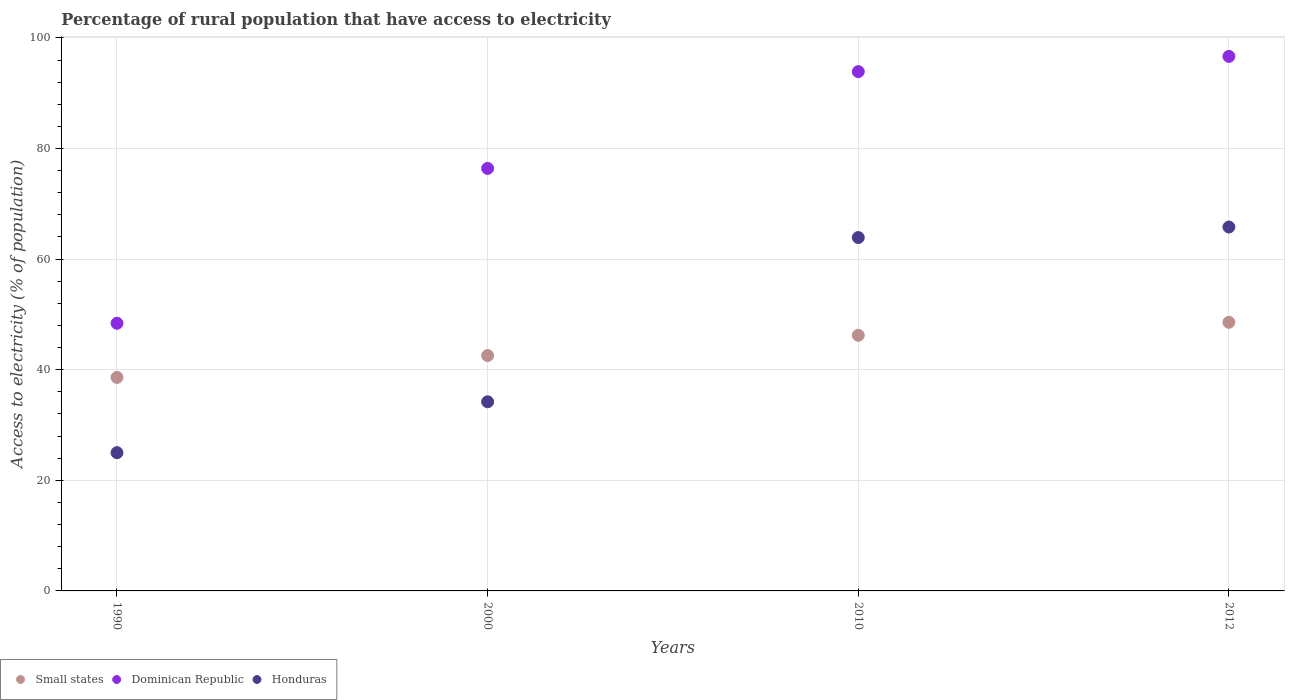How many different coloured dotlines are there?
Ensure brevity in your answer.  3. What is the percentage of rural population that have access to electricity in Small states in 2000?
Your response must be concise. 42.56. Across all years, what is the maximum percentage of rural population that have access to electricity in Dominican Republic?
Provide a succinct answer. 96.65. Across all years, what is the minimum percentage of rural population that have access to electricity in Honduras?
Offer a terse response. 25. In which year was the percentage of rural population that have access to electricity in Small states maximum?
Your answer should be compact. 2012. In which year was the percentage of rural population that have access to electricity in Honduras minimum?
Make the answer very short. 1990. What is the total percentage of rural population that have access to electricity in Dominican Republic in the graph?
Offer a terse response. 315.35. What is the difference between the percentage of rural population that have access to electricity in Small states in 1990 and that in 2012?
Offer a terse response. -9.96. What is the difference between the percentage of rural population that have access to electricity in Small states in 1990 and the percentage of rural population that have access to electricity in Dominican Republic in 2012?
Ensure brevity in your answer.  -58.05. What is the average percentage of rural population that have access to electricity in Small states per year?
Make the answer very short. 43.99. In the year 2000, what is the difference between the percentage of rural population that have access to electricity in Dominican Republic and percentage of rural population that have access to electricity in Honduras?
Keep it short and to the point. 42.2. What is the ratio of the percentage of rural population that have access to electricity in Small states in 1990 to that in 2000?
Offer a very short reply. 0.91. Is the percentage of rural population that have access to electricity in Small states in 2000 less than that in 2010?
Make the answer very short. Yes. Is the difference between the percentage of rural population that have access to electricity in Dominican Republic in 1990 and 2000 greater than the difference between the percentage of rural population that have access to electricity in Honduras in 1990 and 2000?
Offer a terse response. No. What is the difference between the highest and the second highest percentage of rural population that have access to electricity in Small states?
Your response must be concise. 2.35. What is the difference between the highest and the lowest percentage of rural population that have access to electricity in Dominican Republic?
Offer a very short reply. 48.25. Is it the case that in every year, the sum of the percentage of rural population that have access to electricity in Dominican Republic and percentage of rural population that have access to electricity in Honduras  is greater than the percentage of rural population that have access to electricity in Small states?
Your answer should be compact. Yes. Is the percentage of rural population that have access to electricity in Small states strictly greater than the percentage of rural population that have access to electricity in Dominican Republic over the years?
Ensure brevity in your answer.  No. How many years are there in the graph?
Keep it short and to the point. 4. What is the difference between two consecutive major ticks on the Y-axis?
Make the answer very short. 20. Does the graph contain any zero values?
Offer a very short reply. No. Where does the legend appear in the graph?
Make the answer very short. Bottom left. How many legend labels are there?
Offer a very short reply. 3. How are the legend labels stacked?
Give a very brief answer. Horizontal. What is the title of the graph?
Make the answer very short. Percentage of rural population that have access to electricity. What is the label or title of the Y-axis?
Your response must be concise. Access to electricity (% of population). What is the Access to electricity (% of population) of Small states in 1990?
Offer a terse response. 38.61. What is the Access to electricity (% of population) in Dominican Republic in 1990?
Offer a very short reply. 48.4. What is the Access to electricity (% of population) in Honduras in 1990?
Offer a very short reply. 25. What is the Access to electricity (% of population) of Small states in 2000?
Provide a succinct answer. 42.56. What is the Access to electricity (% of population) of Dominican Republic in 2000?
Offer a terse response. 76.4. What is the Access to electricity (% of population) of Honduras in 2000?
Your response must be concise. 34.2. What is the Access to electricity (% of population) of Small states in 2010?
Offer a terse response. 46.22. What is the Access to electricity (% of population) in Dominican Republic in 2010?
Offer a terse response. 93.9. What is the Access to electricity (% of population) in Honduras in 2010?
Make the answer very short. 63.9. What is the Access to electricity (% of population) in Small states in 2012?
Provide a short and direct response. 48.57. What is the Access to electricity (% of population) in Dominican Republic in 2012?
Ensure brevity in your answer.  96.65. What is the Access to electricity (% of population) of Honduras in 2012?
Your response must be concise. 65.8. Across all years, what is the maximum Access to electricity (% of population) in Small states?
Offer a terse response. 48.57. Across all years, what is the maximum Access to electricity (% of population) of Dominican Republic?
Your response must be concise. 96.65. Across all years, what is the maximum Access to electricity (% of population) in Honduras?
Give a very brief answer. 65.8. Across all years, what is the minimum Access to electricity (% of population) of Small states?
Keep it short and to the point. 38.61. Across all years, what is the minimum Access to electricity (% of population) of Dominican Republic?
Ensure brevity in your answer.  48.4. What is the total Access to electricity (% of population) in Small states in the graph?
Provide a short and direct response. 175.96. What is the total Access to electricity (% of population) in Dominican Republic in the graph?
Offer a very short reply. 315.35. What is the total Access to electricity (% of population) of Honduras in the graph?
Offer a terse response. 188.9. What is the difference between the Access to electricity (% of population) of Small states in 1990 and that in 2000?
Keep it short and to the point. -3.95. What is the difference between the Access to electricity (% of population) of Honduras in 1990 and that in 2000?
Offer a very short reply. -9.2. What is the difference between the Access to electricity (% of population) of Small states in 1990 and that in 2010?
Offer a terse response. -7.62. What is the difference between the Access to electricity (% of population) of Dominican Republic in 1990 and that in 2010?
Your answer should be very brief. -45.5. What is the difference between the Access to electricity (% of population) in Honduras in 1990 and that in 2010?
Provide a succinct answer. -38.9. What is the difference between the Access to electricity (% of population) in Small states in 1990 and that in 2012?
Your answer should be very brief. -9.96. What is the difference between the Access to electricity (% of population) in Dominican Republic in 1990 and that in 2012?
Ensure brevity in your answer.  -48.25. What is the difference between the Access to electricity (% of population) in Honduras in 1990 and that in 2012?
Make the answer very short. -40.8. What is the difference between the Access to electricity (% of population) in Small states in 2000 and that in 2010?
Your answer should be very brief. -3.66. What is the difference between the Access to electricity (% of population) of Dominican Republic in 2000 and that in 2010?
Your answer should be very brief. -17.5. What is the difference between the Access to electricity (% of population) in Honduras in 2000 and that in 2010?
Your response must be concise. -29.7. What is the difference between the Access to electricity (% of population) in Small states in 2000 and that in 2012?
Make the answer very short. -6.01. What is the difference between the Access to electricity (% of population) in Dominican Republic in 2000 and that in 2012?
Offer a terse response. -20.25. What is the difference between the Access to electricity (% of population) of Honduras in 2000 and that in 2012?
Provide a short and direct response. -31.6. What is the difference between the Access to electricity (% of population) of Small states in 2010 and that in 2012?
Offer a very short reply. -2.35. What is the difference between the Access to electricity (% of population) in Dominican Republic in 2010 and that in 2012?
Make the answer very short. -2.75. What is the difference between the Access to electricity (% of population) in Honduras in 2010 and that in 2012?
Ensure brevity in your answer.  -1.9. What is the difference between the Access to electricity (% of population) in Small states in 1990 and the Access to electricity (% of population) in Dominican Republic in 2000?
Your answer should be very brief. -37.79. What is the difference between the Access to electricity (% of population) in Small states in 1990 and the Access to electricity (% of population) in Honduras in 2000?
Keep it short and to the point. 4.41. What is the difference between the Access to electricity (% of population) of Dominican Republic in 1990 and the Access to electricity (% of population) of Honduras in 2000?
Your answer should be compact. 14.2. What is the difference between the Access to electricity (% of population) of Small states in 1990 and the Access to electricity (% of population) of Dominican Republic in 2010?
Make the answer very short. -55.29. What is the difference between the Access to electricity (% of population) of Small states in 1990 and the Access to electricity (% of population) of Honduras in 2010?
Offer a terse response. -25.29. What is the difference between the Access to electricity (% of population) in Dominican Republic in 1990 and the Access to electricity (% of population) in Honduras in 2010?
Provide a succinct answer. -15.5. What is the difference between the Access to electricity (% of population) of Small states in 1990 and the Access to electricity (% of population) of Dominican Republic in 2012?
Ensure brevity in your answer.  -58.05. What is the difference between the Access to electricity (% of population) of Small states in 1990 and the Access to electricity (% of population) of Honduras in 2012?
Your response must be concise. -27.19. What is the difference between the Access to electricity (% of population) of Dominican Republic in 1990 and the Access to electricity (% of population) of Honduras in 2012?
Offer a very short reply. -17.4. What is the difference between the Access to electricity (% of population) of Small states in 2000 and the Access to electricity (% of population) of Dominican Republic in 2010?
Your answer should be very brief. -51.34. What is the difference between the Access to electricity (% of population) in Small states in 2000 and the Access to electricity (% of population) in Honduras in 2010?
Provide a succinct answer. -21.34. What is the difference between the Access to electricity (% of population) in Small states in 2000 and the Access to electricity (% of population) in Dominican Republic in 2012?
Offer a terse response. -54.09. What is the difference between the Access to electricity (% of population) in Small states in 2000 and the Access to electricity (% of population) in Honduras in 2012?
Provide a short and direct response. -23.24. What is the difference between the Access to electricity (% of population) in Dominican Republic in 2000 and the Access to electricity (% of population) in Honduras in 2012?
Ensure brevity in your answer.  10.6. What is the difference between the Access to electricity (% of population) in Small states in 2010 and the Access to electricity (% of population) in Dominican Republic in 2012?
Offer a terse response. -50.43. What is the difference between the Access to electricity (% of population) of Small states in 2010 and the Access to electricity (% of population) of Honduras in 2012?
Make the answer very short. -19.58. What is the difference between the Access to electricity (% of population) in Dominican Republic in 2010 and the Access to electricity (% of population) in Honduras in 2012?
Your answer should be very brief. 28.1. What is the average Access to electricity (% of population) in Small states per year?
Make the answer very short. 43.99. What is the average Access to electricity (% of population) in Dominican Republic per year?
Your answer should be compact. 78.84. What is the average Access to electricity (% of population) in Honduras per year?
Offer a very short reply. 47.23. In the year 1990, what is the difference between the Access to electricity (% of population) in Small states and Access to electricity (% of population) in Dominican Republic?
Your response must be concise. -9.79. In the year 1990, what is the difference between the Access to electricity (% of population) in Small states and Access to electricity (% of population) in Honduras?
Your answer should be compact. 13.61. In the year 1990, what is the difference between the Access to electricity (% of population) in Dominican Republic and Access to electricity (% of population) in Honduras?
Ensure brevity in your answer.  23.4. In the year 2000, what is the difference between the Access to electricity (% of population) of Small states and Access to electricity (% of population) of Dominican Republic?
Provide a short and direct response. -33.84. In the year 2000, what is the difference between the Access to electricity (% of population) in Small states and Access to electricity (% of population) in Honduras?
Your answer should be compact. 8.36. In the year 2000, what is the difference between the Access to electricity (% of population) of Dominican Republic and Access to electricity (% of population) of Honduras?
Your answer should be very brief. 42.2. In the year 2010, what is the difference between the Access to electricity (% of population) of Small states and Access to electricity (% of population) of Dominican Republic?
Give a very brief answer. -47.68. In the year 2010, what is the difference between the Access to electricity (% of population) of Small states and Access to electricity (% of population) of Honduras?
Make the answer very short. -17.68. In the year 2010, what is the difference between the Access to electricity (% of population) in Dominican Republic and Access to electricity (% of population) in Honduras?
Offer a very short reply. 30. In the year 2012, what is the difference between the Access to electricity (% of population) in Small states and Access to electricity (% of population) in Dominican Republic?
Ensure brevity in your answer.  -48.08. In the year 2012, what is the difference between the Access to electricity (% of population) in Small states and Access to electricity (% of population) in Honduras?
Keep it short and to the point. -17.23. In the year 2012, what is the difference between the Access to electricity (% of population) of Dominican Republic and Access to electricity (% of population) of Honduras?
Keep it short and to the point. 30.85. What is the ratio of the Access to electricity (% of population) in Small states in 1990 to that in 2000?
Make the answer very short. 0.91. What is the ratio of the Access to electricity (% of population) of Dominican Republic in 1990 to that in 2000?
Offer a terse response. 0.63. What is the ratio of the Access to electricity (% of population) in Honduras in 1990 to that in 2000?
Your response must be concise. 0.73. What is the ratio of the Access to electricity (% of population) in Small states in 1990 to that in 2010?
Provide a succinct answer. 0.84. What is the ratio of the Access to electricity (% of population) in Dominican Republic in 1990 to that in 2010?
Your answer should be very brief. 0.52. What is the ratio of the Access to electricity (% of population) of Honduras in 1990 to that in 2010?
Your answer should be compact. 0.39. What is the ratio of the Access to electricity (% of population) of Small states in 1990 to that in 2012?
Offer a terse response. 0.79. What is the ratio of the Access to electricity (% of population) in Dominican Republic in 1990 to that in 2012?
Provide a short and direct response. 0.5. What is the ratio of the Access to electricity (% of population) in Honduras in 1990 to that in 2012?
Give a very brief answer. 0.38. What is the ratio of the Access to electricity (% of population) of Small states in 2000 to that in 2010?
Ensure brevity in your answer.  0.92. What is the ratio of the Access to electricity (% of population) in Dominican Republic in 2000 to that in 2010?
Provide a succinct answer. 0.81. What is the ratio of the Access to electricity (% of population) in Honduras in 2000 to that in 2010?
Offer a terse response. 0.54. What is the ratio of the Access to electricity (% of population) in Small states in 2000 to that in 2012?
Offer a very short reply. 0.88. What is the ratio of the Access to electricity (% of population) in Dominican Republic in 2000 to that in 2012?
Keep it short and to the point. 0.79. What is the ratio of the Access to electricity (% of population) of Honduras in 2000 to that in 2012?
Your answer should be compact. 0.52. What is the ratio of the Access to electricity (% of population) of Small states in 2010 to that in 2012?
Your answer should be compact. 0.95. What is the ratio of the Access to electricity (% of population) in Dominican Republic in 2010 to that in 2012?
Offer a terse response. 0.97. What is the ratio of the Access to electricity (% of population) in Honduras in 2010 to that in 2012?
Provide a short and direct response. 0.97. What is the difference between the highest and the second highest Access to electricity (% of population) in Small states?
Keep it short and to the point. 2.35. What is the difference between the highest and the second highest Access to electricity (% of population) of Dominican Republic?
Your response must be concise. 2.75. What is the difference between the highest and the lowest Access to electricity (% of population) in Small states?
Provide a succinct answer. 9.96. What is the difference between the highest and the lowest Access to electricity (% of population) in Dominican Republic?
Keep it short and to the point. 48.25. What is the difference between the highest and the lowest Access to electricity (% of population) of Honduras?
Keep it short and to the point. 40.8. 